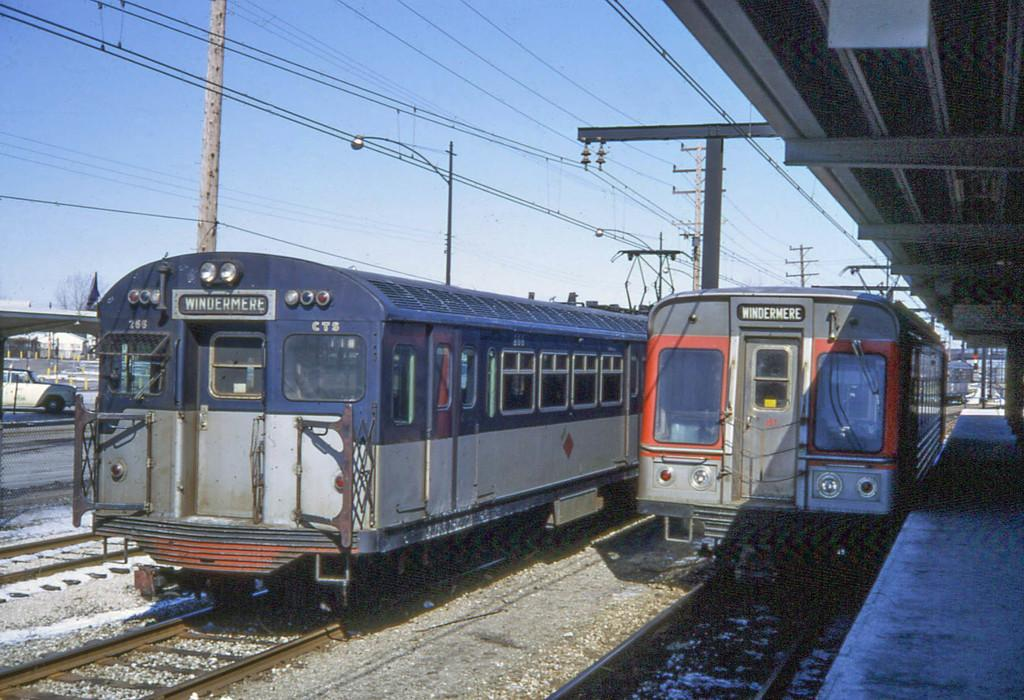What type of vehicles can be seen in the image? There are trains in the image. What structures are present in the image? There are transmission towers and a metal frame in the image. What is the purpose of the metal frame? The metal frame might be used for supporting structures or equipment. What is the setting for the trains in the image? There is a platform in the image where the trains might be stationed or boarded. What type of vegetation is visible in the image? There are trees in the image. What is visible at the top of the image? The sky is visible at the top of the image. What type of sack is being used to mine for resources in the image? There is no sack or mining activity present in the image; it features trains, transmission towers, a metal frame, a platform, trees, and the sky. 